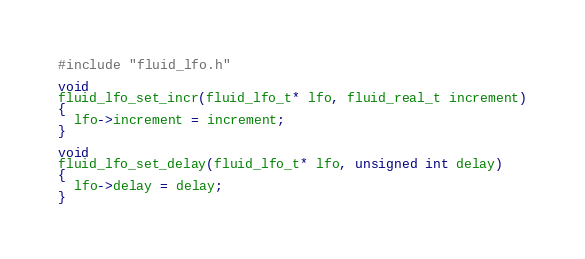<code> <loc_0><loc_0><loc_500><loc_500><_C_>#include "fluid_lfo.h"

void
fluid_lfo_set_incr(fluid_lfo_t* lfo, fluid_real_t increment)
{
  lfo->increment = increment;
}

void
fluid_lfo_set_delay(fluid_lfo_t* lfo, unsigned int delay)
{
  lfo->delay = delay;
}
</code> 